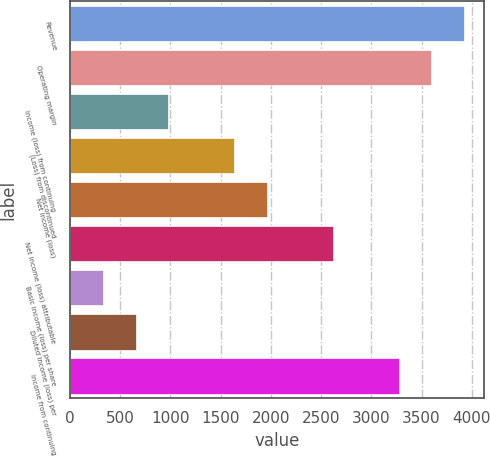<chart> <loc_0><loc_0><loc_500><loc_500><bar_chart><fcel>Revenue<fcel>Operating margin<fcel>Income (loss) from continuing<fcel>(Loss) from discontinued<fcel>Net income (loss)<fcel>Net income (loss) attributable<fcel>Basic income (loss) per share<fcel>Diluted income (loss) per<fcel>Income from continuing<nl><fcel>3925.21<fcel>3598.11<fcel>981.31<fcel>1635.51<fcel>1962.61<fcel>2616.81<fcel>327.11<fcel>654.21<fcel>3271.01<nl></chart> 